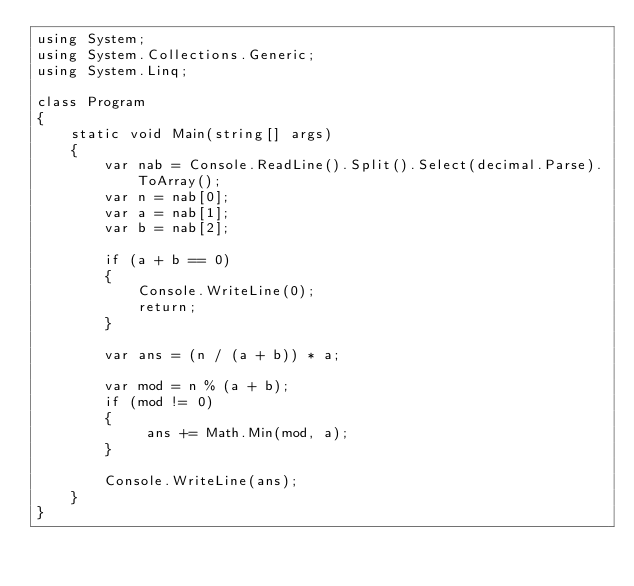<code> <loc_0><loc_0><loc_500><loc_500><_C#_>using System;
using System.Collections.Generic;
using System.Linq;

class Program
{
    static void Main(string[] args)
    {
        var nab = Console.ReadLine().Split().Select(decimal.Parse).ToArray();
        var n = nab[0];
        var a = nab[1];
        var b = nab[2];

        if (a + b == 0)
        {
            Console.WriteLine(0);
            return;
        }

        var ans = (n / (a + b)) * a;

        var mod = n % (a + b);
        if (mod != 0)
        {
             ans += Math.Min(mod, a);
        }

        Console.WriteLine(ans);
    }
}
</code> 